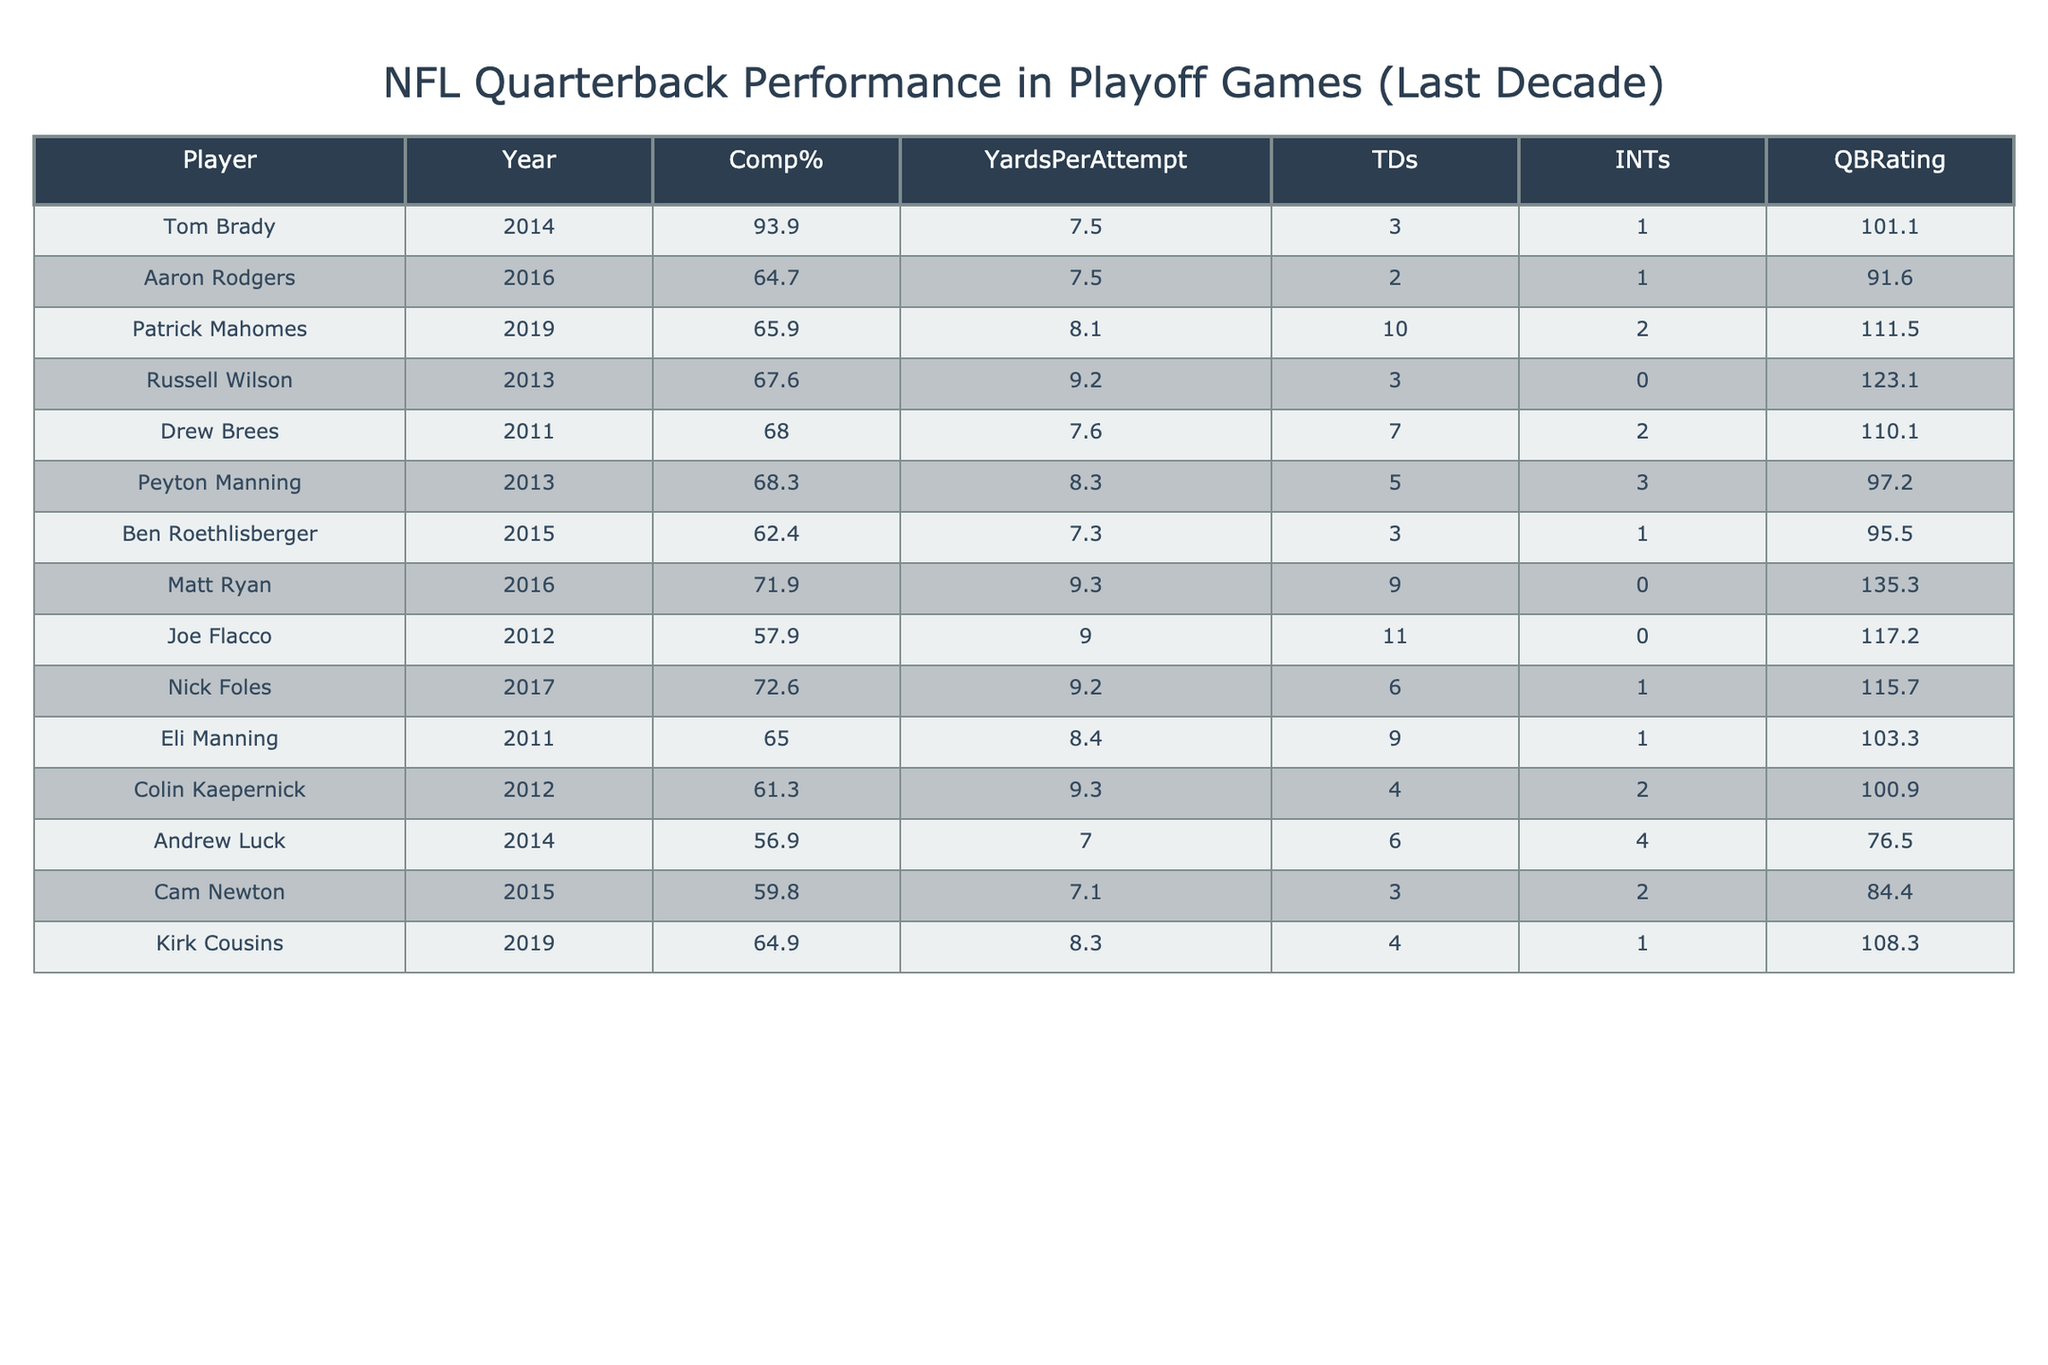What is the completion percentage for Tom Brady in 2014? The table shows Tom Brady's performance in 2014, with a completion percentage listed as 93.9%.
Answer: 93.9% Who has the highest QBRating among the quarterbacks listed? By looking at the QBRating column in the table, Matt Ryan has the highest rating of 135.3.
Answer: 135.3 What is the average number of touchdowns scored by the quarterbacks in the table? Adding the total touchdowns (3 + 2 + 10 + 3 + 7 + 5 + 3 + 9 + 11 + 6 + 9 + 4 + 6 + 3 + 4) gives 81 touchdowns. There are 15 players, so the average is 81/15 = 5.4.
Answer: 5.4 Did any quarterback have no interceptions in their playoff game? The table shows players like Russell Wilson, Matt Ryan, and Joe Flacco, who all had 0 interceptions. Thus, the answer is yes.
Answer: Yes Which quarterback had the most yards per attempt and what was the value? Reviewing the Yards Per Attempt column, Matt Ryan recorded 9.3 yards per attempt, which is the highest among those listed.
Answer: 9.3 How many quarterbacks had a completion percentage below 60%? Checking the completion percentages, Andrew Luck (56.9%) and Cam Newton (59.8%) are below 60%. Therefore, there are 2 quarterbacks meeting this criterion.
Answer: 2 If we list the quarterbacks with a QBRating above 100, how many are there? The quarterbacks with a QBRating above 100 are Tom Brady, Patrick Mahomes, Russell Wilson, Drew Brees, Matt Ryan, Joe Flacco, and Nick Foles, totaling 7 players.
Answer: 7 What is the difference in touchdowns between Patrick Mahomes and Ben Roethlisberger? Patrick Mahomes had 10 touchdowns, while Ben Roethlisberger had 3 touchdowns. The difference is 10 - 3 = 7.
Answer: 7 Was Cam Newton's completion percentage higher than that of Andrew Luck? Cam Newton's completion percentage was 59.8%, and Andrew Luck's was 56.9%. Since 59.8% is greater than 56.9%, the answer is yes.
Answer: Yes Which quarterback had the highest number of interceptions, and how many were there? By examining the Interceptions column, Andrew Luck had the most interceptions with a count of 4.
Answer: 4 